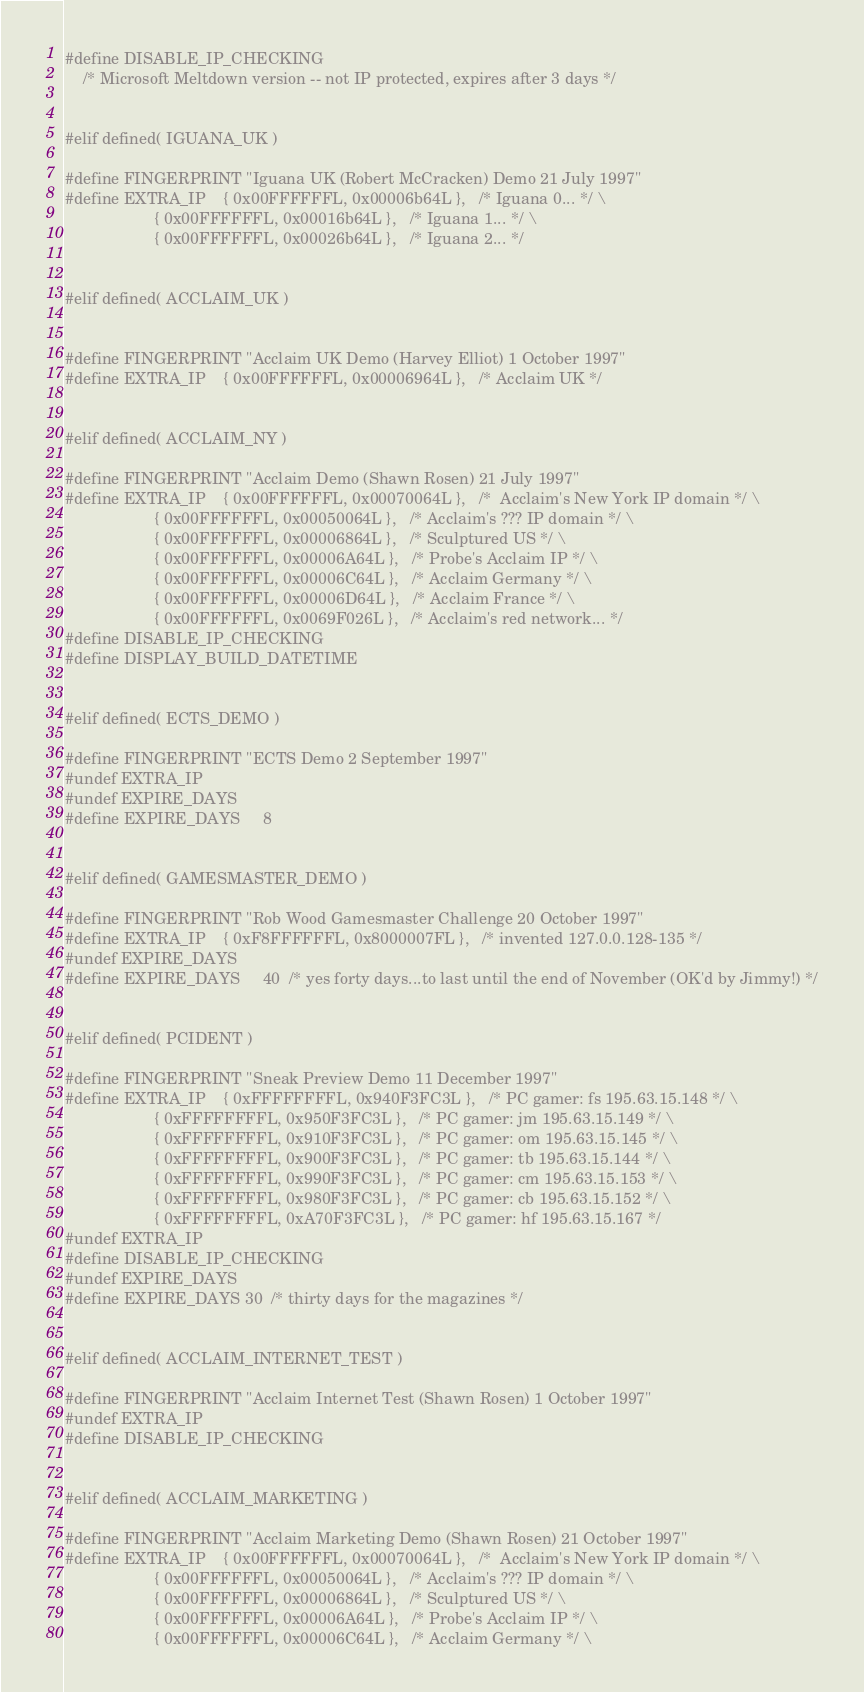Convert code to text. <code><loc_0><loc_0><loc_500><loc_500><_C_>#define DISABLE_IP_CHECKING
    /* Microsoft Meltdown version -- not IP protected, expires after 3 days */


#elif defined( IGUANA_UK )

#define FINGERPRINT "Iguana UK (Robert McCracken) Demo 21 July 1997"
#define EXTRA_IP    { 0x00FFFFFFL, 0x00006b64L },   /* Iguana 0... */ \
                    { 0x00FFFFFFL, 0x00016b64L },   /* Iguana 1... */ \
                    { 0x00FFFFFFL, 0x00026b64L },   /* Iguana 2... */


#elif defined( ACCLAIM_UK )


#define FINGERPRINT "Acclaim UK Demo (Harvey Elliot) 1 October 1997"
#define EXTRA_IP    { 0x00FFFFFFL, 0x00006964L },   /* Acclaim UK */


#elif defined( ACCLAIM_NY )

#define FINGERPRINT "Acclaim Demo (Shawn Rosen) 21 July 1997"
#define EXTRA_IP    { 0x00FFFFFFL, 0x00070064L },   /*  Acclaim's New York IP domain */ \
                    { 0x00FFFFFFL, 0x00050064L },   /* Acclaim's ??? IP domain */ \
                    { 0x00FFFFFFL, 0x00006864L },   /* Sculptured US */ \
                    { 0x00FFFFFFL, 0x00006A64L },   /* Probe's Acclaim IP */ \
                    { 0x00FFFFFFL, 0x00006C64L },   /* Acclaim Germany */ \
                    { 0x00FFFFFFL, 0x00006D64L },   /* Acclaim France */ \
                    { 0x00FFFFFFL, 0x0069F026L },   /* Acclaim's red network... */
#define DISABLE_IP_CHECKING
#define DISPLAY_BUILD_DATETIME


#elif defined( ECTS_DEMO )

#define FINGERPRINT "ECTS Demo 2 September 1997"
#undef EXTRA_IP
#undef EXPIRE_DAYS
#define EXPIRE_DAYS     8


#elif defined( GAMESMASTER_DEMO )

#define FINGERPRINT "Rob Wood Gamesmaster Challenge 20 October 1997"
#define EXTRA_IP    { 0xF8FFFFFFL, 0x8000007FL },   /* invented 127.0.0.128-135 */
#undef EXPIRE_DAYS
#define EXPIRE_DAYS     40  /* yes forty days...to last until the end of November (OK'd by Jimmy!) */


#elif defined( PCIDENT )

#define FINGERPRINT "Sneak Preview Demo 11 December 1997"
#define EXTRA_IP    { 0xFFFFFFFFL, 0x940F3FC3L },   /* PC gamer: fs 195.63.15.148 */ \
                    { 0xFFFFFFFFL, 0x950F3FC3L },   /* PC gamer: jm 195.63.15.149 */ \
                    { 0xFFFFFFFFL, 0x910F3FC3L },   /* PC gamer: om 195.63.15.145 */ \
                    { 0xFFFFFFFFL, 0x900F3FC3L },   /* PC gamer: tb 195.63.15.144 */ \
                    { 0xFFFFFFFFL, 0x990F3FC3L },   /* PC gamer: cm 195.63.15.153 */ \
                    { 0xFFFFFFFFL, 0x980F3FC3L },   /* PC gamer: cb 195.63.15.152 */ \
                    { 0xFFFFFFFFL, 0xA70F3FC3L },   /* PC gamer: hf 195.63.15.167 */
#undef EXTRA_IP
#define DISABLE_IP_CHECKING
#undef EXPIRE_DAYS
#define EXPIRE_DAYS 30  /* thirty days for the magazines */


#elif defined( ACCLAIM_INTERNET_TEST )

#define FINGERPRINT "Acclaim Internet Test (Shawn Rosen) 1 October 1997"
#undef EXTRA_IP
#define DISABLE_IP_CHECKING


#elif defined( ACCLAIM_MARKETING )

#define FINGERPRINT "Acclaim Marketing Demo (Shawn Rosen) 21 October 1997"
#define EXTRA_IP    { 0x00FFFFFFL, 0x00070064L },   /*  Acclaim's New York IP domain */ \
                    { 0x00FFFFFFL, 0x00050064L },   /* Acclaim's ??? IP domain */ \
                    { 0x00FFFFFFL, 0x00006864L },   /* Sculptured US */ \
                    { 0x00FFFFFFL, 0x00006A64L },   /* Probe's Acclaim IP */ \
                    { 0x00FFFFFFL, 0x00006C64L },   /* Acclaim Germany */ \</code> 